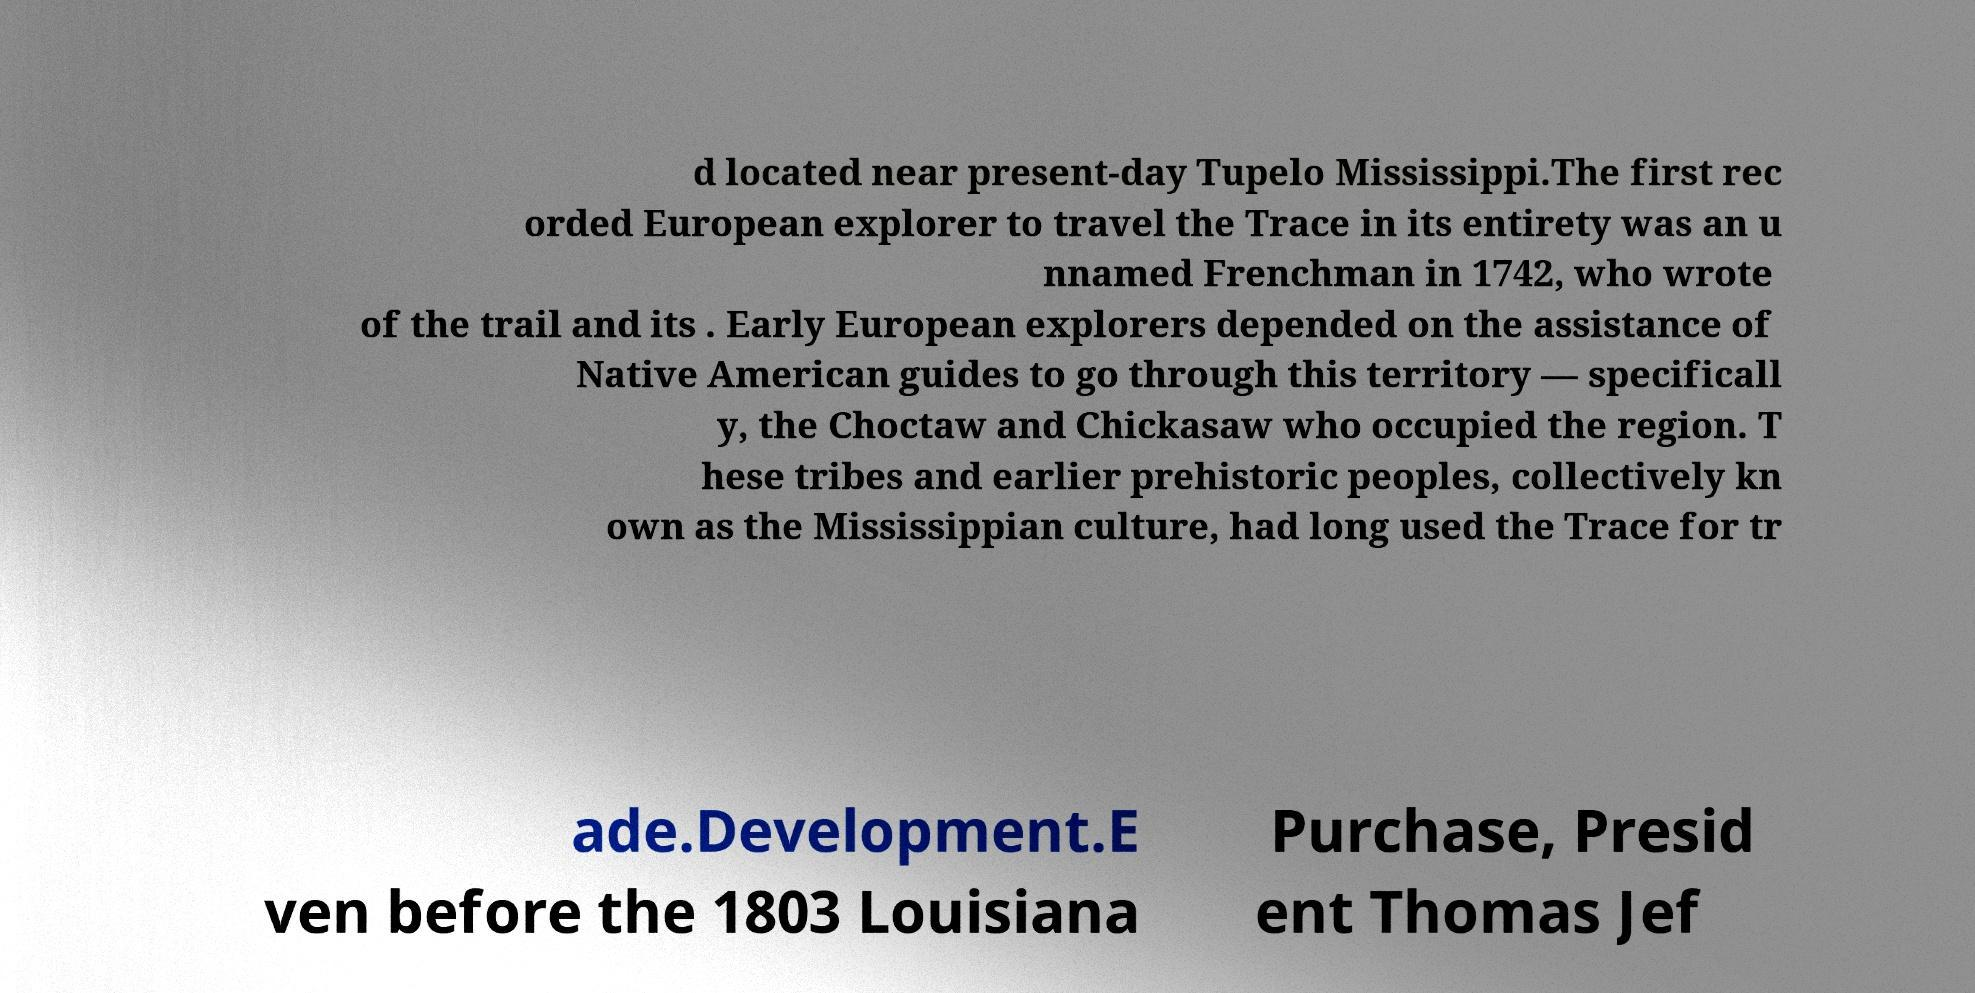There's text embedded in this image that I need extracted. Can you transcribe it verbatim? d located near present-day Tupelo Mississippi.The first rec orded European explorer to travel the Trace in its entirety was an u nnamed Frenchman in 1742, who wrote of the trail and its . Early European explorers depended on the assistance of Native American guides to go through this territory — specificall y, the Choctaw and Chickasaw who occupied the region. T hese tribes and earlier prehistoric peoples, collectively kn own as the Mississippian culture, had long used the Trace for tr ade.Development.E ven before the 1803 Louisiana Purchase, Presid ent Thomas Jef 